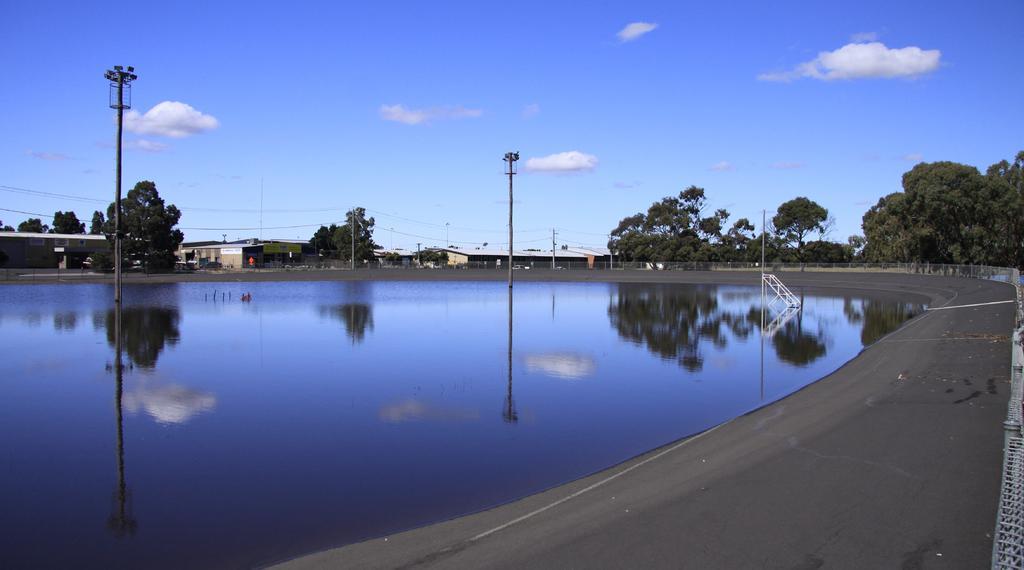Please provide a concise description of this image. In the foreground of this image, there is a pavement, railing and the water. Few poles in the water. In the background, there are buildings, trees, sky and the cloud. 